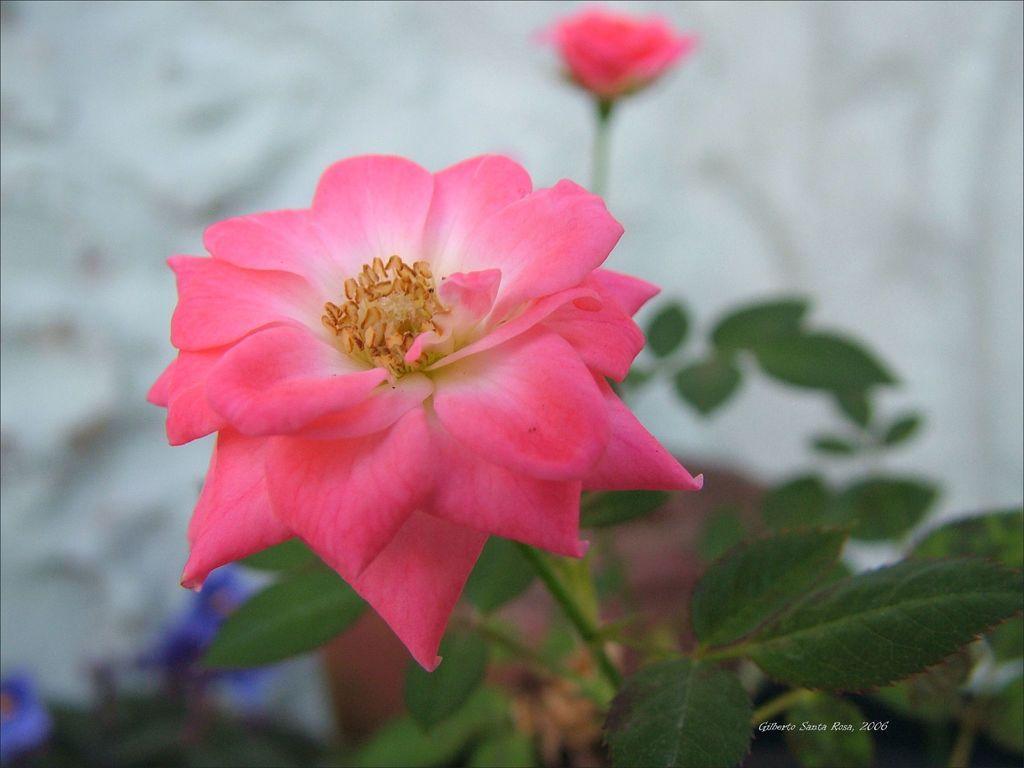Describe this image in one or two sentences. In this image, in the middle, we can see a flower which is in pink color. On the right side, we can see a plant with green leaves. In the background, we can also see another flower and a white color. On the left side, we can see blue color flowers. 